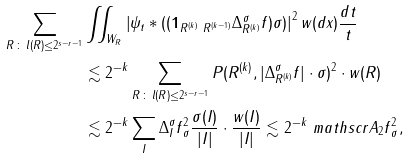Convert formula to latex. <formula><loc_0><loc_0><loc_500><loc_500>\sum _ { R \, \colon \, l ( R ) \leq 2 ^ { s - r - 1 } } & \iint _ { W _ { R } } \left | \psi _ { t } * ( ( \mathbf 1 _ { R ^ { ( k ) } \ R ^ { ( k - 1 ) } } \Delta _ { R ^ { ( k ) } } ^ { \sigma } f ) \sigma ) \right | ^ { 2 } w ( d x ) \frac { d t } { t } \\ & \lesssim 2 ^ { - k } \sum _ { R \, \colon \, l ( R ) \leq 2 ^ { s - r - 1 } } P ( R ^ { ( k ) } , | \Delta _ { R ^ { ( k ) } } ^ { \sigma } f | \cdot \sigma ) ^ { 2 } \cdot { w ( R ) } \\ & \lesssim 2 ^ { - k } \sum _ { I } \| \Delta ^ { \sigma } _ { I } f \| _ { \sigma } ^ { 2 } \frac { \sigma ( I ) } { | I | } \cdot \frac { w ( I ) } { | I | } \lesssim 2 ^ { - k } \ m a t h s c r A _ { 2 } \| f \| _ { \sigma } ^ { 2 } ,</formula> 